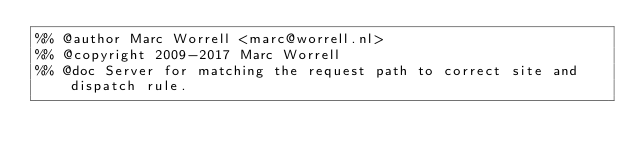Convert code to text. <code><loc_0><loc_0><loc_500><loc_500><_Erlang_>%% @author Marc Worrell <marc@worrell.nl>
%% @copyright 2009-2017 Marc Worrell
%% @doc Server for matching the request path to correct site and dispatch rule.
</code> 